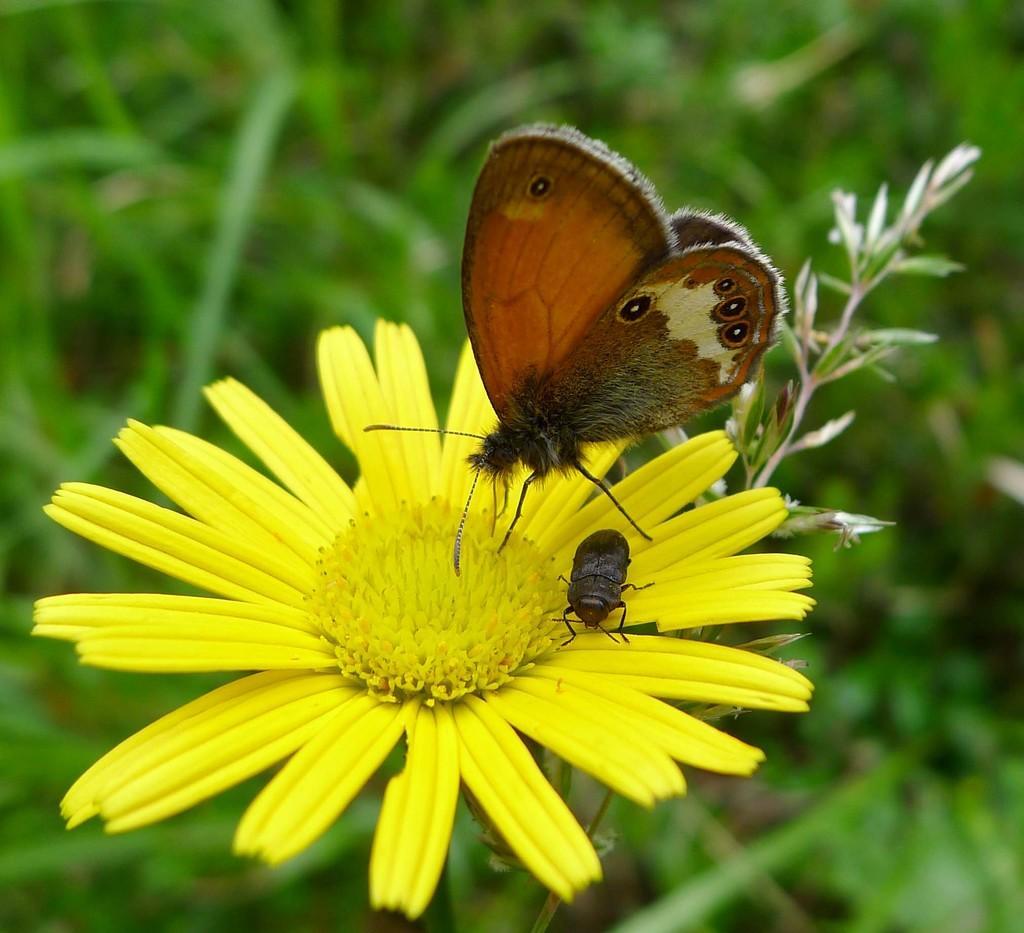Can you describe this image briefly? There is a butterfly and an insect on a yellow color sunflower and there are few green plants in the background. 